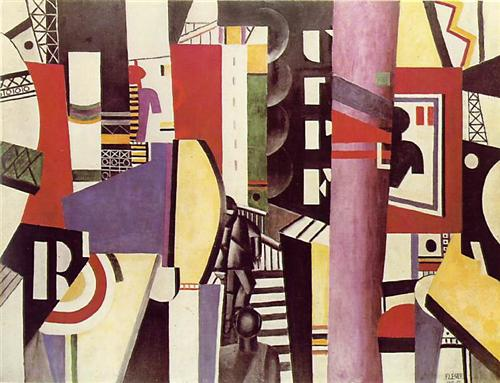Pretend you can step into the painting. Describe what you see, hear, and feel. Stepping into the painting, you find yourself in a world where geometry rules everything. The ground beneath your feet feels both solid and surreal, composed of interlocking shapes that shift subtly as you walk. The air hums with the energetic buzz of vibrant colors intertwining and moving around you. Each step resonates a unique tone, creating a symphony of abstract music. Around you, towering structures of multifaceted forms stretch towards the sky, appearing both futuristic and timeless. The world feels alive with an electric energy, and there's a sense of constant motion and change, as if the artwork itself is breathing and evolving. You feel a mixture of exhilaration and curiosity, as you become an explorer uncovering the myriad layers and dimensions of this beautifully complex universe. 